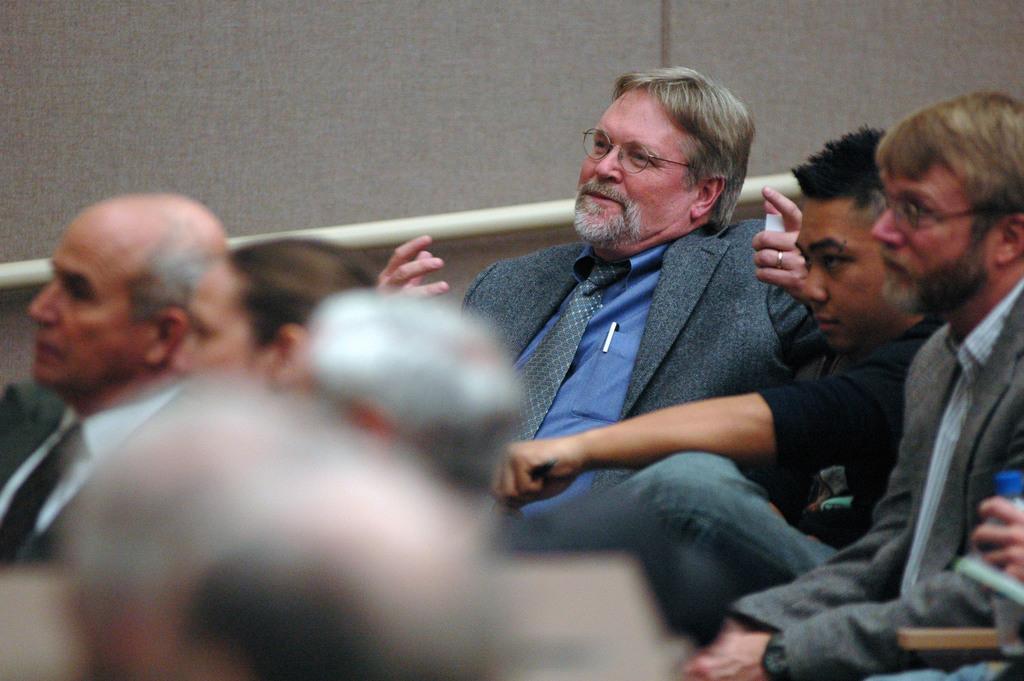Please provide a concise description of this image. In the foreground of this picture we can see the group of people sitting. In the left corner we can see the hand of a person holding the bottle. In the background we can see the metal rod and an object which seems to be the wall. 